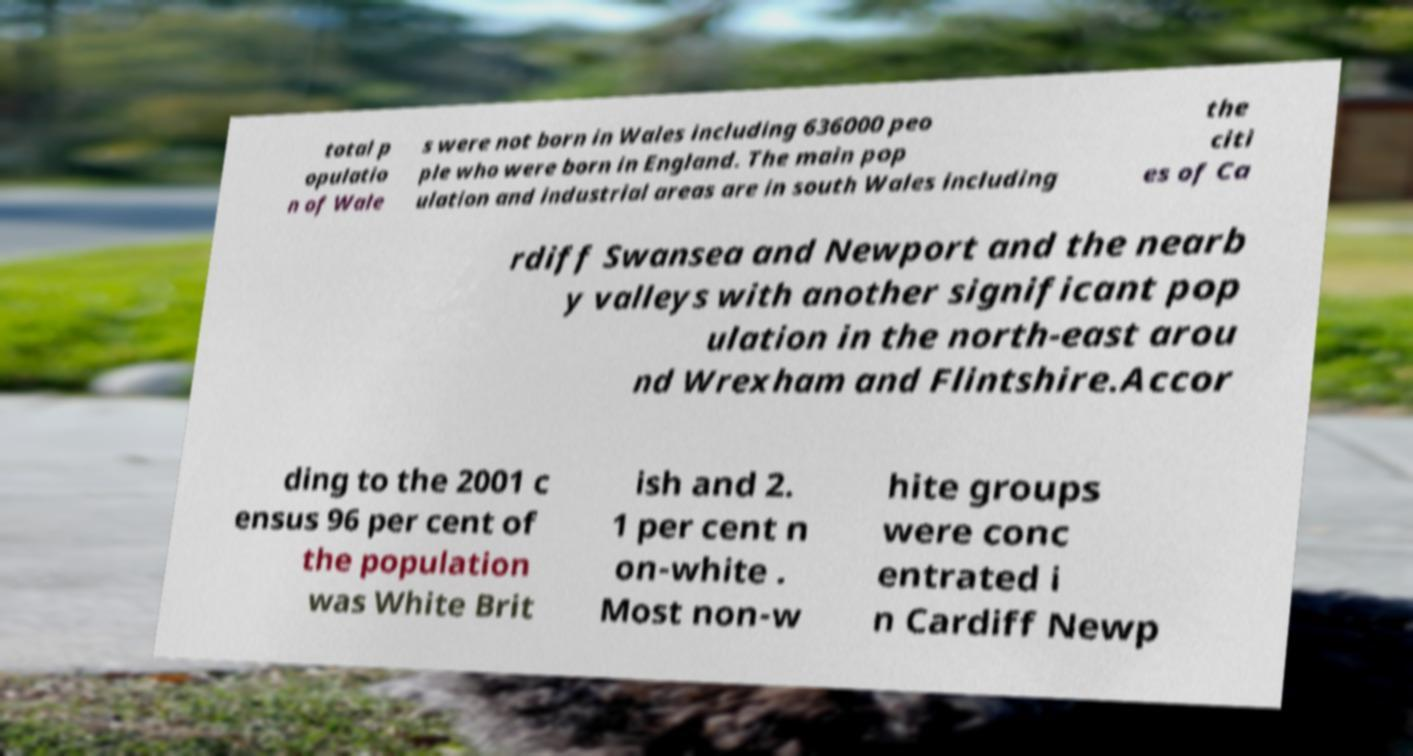Please identify and transcribe the text found in this image. total p opulatio n of Wale s were not born in Wales including 636000 peo ple who were born in England. The main pop ulation and industrial areas are in south Wales including the citi es of Ca rdiff Swansea and Newport and the nearb y valleys with another significant pop ulation in the north-east arou nd Wrexham and Flintshire.Accor ding to the 2001 c ensus 96 per cent of the population was White Brit ish and 2. 1 per cent n on-white . Most non-w hite groups were conc entrated i n Cardiff Newp 